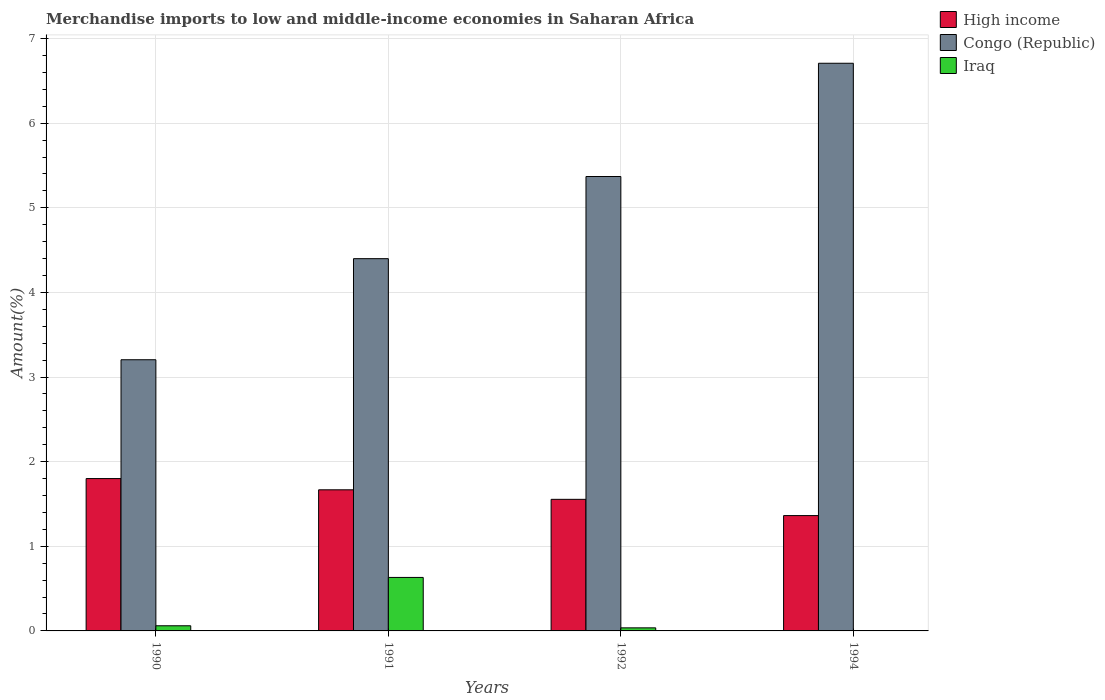How many different coloured bars are there?
Keep it short and to the point. 3. Are the number of bars per tick equal to the number of legend labels?
Offer a terse response. Yes. Are the number of bars on each tick of the X-axis equal?
Your answer should be very brief. Yes. How many bars are there on the 4th tick from the right?
Offer a very short reply. 3. In how many cases, is the number of bars for a given year not equal to the number of legend labels?
Provide a succinct answer. 0. What is the percentage of amount earned from merchandise imports in Iraq in 1990?
Give a very brief answer. 0.06. Across all years, what is the maximum percentage of amount earned from merchandise imports in High income?
Offer a very short reply. 1.8. Across all years, what is the minimum percentage of amount earned from merchandise imports in High income?
Your answer should be very brief. 1.36. In which year was the percentage of amount earned from merchandise imports in High income minimum?
Ensure brevity in your answer.  1994. What is the total percentage of amount earned from merchandise imports in High income in the graph?
Keep it short and to the point. 6.39. What is the difference between the percentage of amount earned from merchandise imports in Iraq in 1990 and that in 1994?
Make the answer very short. 0.06. What is the difference between the percentage of amount earned from merchandise imports in Congo (Republic) in 1994 and the percentage of amount earned from merchandise imports in Iraq in 1990?
Provide a succinct answer. 6.65. What is the average percentage of amount earned from merchandise imports in Congo (Republic) per year?
Give a very brief answer. 4.92. In the year 1992, what is the difference between the percentage of amount earned from merchandise imports in Congo (Republic) and percentage of amount earned from merchandise imports in Iraq?
Ensure brevity in your answer.  5.33. What is the ratio of the percentage of amount earned from merchandise imports in Iraq in 1991 to that in 1994?
Ensure brevity in your answer.  8368.13. What is the difference between the highest and the second highest percentage of amount earned from merchandise imports in Iraq?
Give a very brief answer. 0.57. What is the difference between the highest and the lowest percentage of amount earned from merchandise imports in High income?
Your answer should be compact. 0.44. Is the sum of the percentage of amount earned from merchandise imports in Congo (Republic) in 1991 and 1994 greater than the maximum percentage of amount earned from merchandise imports in High income across all years?
Your answer should be compact. Yes. What does the 3rd bar from the left in 1990 represents?
Provide a short and direct response. Iraq. What does the 1st bar from the right in 1990 represents?
Keep it short and to the point. Iraq. Is it the case that in every year, the sum of the percentage of amount earned from merchandise imports in Congo (Republic) and percentage of amount earned from merchandise imports in Iraq is greater than the percentage of amount earned from merchandise imports in High income?
Give a very brief answer. Yes. How are the legend labels stacked?
Provide a succinct answer. Vertical. What is the title of the graph?
Your answer should be compact. Merchandise imports to low and middle-income economies in Saharan Africa. What is the label or title of the X-axis?
Make the answer very short. Years. What is the label or title of the Y-axis?
Provide a short and direct response. Amount(%). What is the Amount(%) in High income in 1990?
Offer a very short reply. 1.8. What is the Amount(%) in Congo (Republic) in 1990?
Your answer should be very brief. 3.2. What is the Amount(%) in Iraq in 1990?
Keep it short and to the point. 0.06. What is the Amount(%) of High income in 1991?
Make the answer very short. 1.67. What is the Amount(%) in Congo (Republic) in 1991?
Your answer should be compact. 4.4. What is the Amount(%) of Iraq in 1991?
Ensure brevity in your answer.  0.63. What is the Amount(%) of High income in 1992?
Ensure brevity in your answer.  1.56. What is the Amount(%) of Congo (Republic) in 1992?
Ensure brevity in your answer.  5.37. What is the Amount(%) of Iraq in 1992?
Your answer should be very brief. 0.04. What is the Amount(%) of High income in 1994?
Ensure brevity in your answer.  1.36. What is the Amount(%) of Congo (Republic) in 1994?
Offer a very short reply. 6.71. What is the Amount(%) of Iraq in 1994?
Provide a short and direct response. 7.554784853766509e-5. Across all years, what is the maximum Amount(%) in High income?
Provide a short and direct response. 1.8. Across all years, what is the maximum Amount(%) in Congo (Republic)?
Offer a very short reply. 6.71. Across all years, what is the maximum Amount(%) in Iraq?
Make the answer very short. 0.63. Across all years, what is the minimum Amount(%) of High income?
Your answer should be compact. 1.36. Across all years, what is the minimum Amount(%) in Congo (Republic)?
Provide a short and direct response. 3.2. Across all years, what is the minimum Amount(%) of Iraq?
Make the answer very short. 7.554784853766509e-5. What is the total Amount(%) in High income in the graph?
Provide a short and direct response. 6.39. What is the total Amount(%) in Congo (Republic) in the graph?
Your answer should be compact. 19.68. What is the total Amount(%) of Iraq in the graph?
Your answer should be very brief. 0.73. What is the difference between the Amount(%) in High income in 1990 and that in 1991?
Provide a succinct answer. 0.13. What is the difference between the Amount(%) in Congo (Republic) in 1990 and that in 1991?
Your answer should be compact. -1.19. What is the difference between the Amount(%) in Iraq in 1990 and that in 1991?
Ensure brevity in your answer.  -0.57. What is the difference between the Amount(%) of High income in 1990 and that in 1992?
Give a very brief answer. 0.25. What is the difference between the Amount(%) of Congo (Republic) in 1990 and that in 1992?
Offer a very short reply. -2.17. What is the difference between the Amount(%) of Iraq in 1990 and that in 1992?
Offer a very short reply. 0.02. What is the difference between the Amount(%) of High income in 1990 and that in 1994?
Make the answer very short. 0.44. What is the difference between the Amount(%) of Congo (Republic) in 1990 and that in 1994?
Give a very brief answer. -3.5. What is the difference between the Amount(%) of Iraq in 1990 and that in 1994?
Your answer should be compact. 0.06. What is the difference between the Amount(%) of High income in 1991 and that in 1992?
Provide a succinct answer. 0.11. What is the difference between the Amount(%) in Congo (Republic) in 1991 and that in 1992?
Your response must be concise. -0.97. What is the difference between the Amount(%) in Iraq in 1991 and that in 1992?
Your response must be concise. 0.6. What is the difference between the Amount(%) of High income in 1991 and that in 1994?
Make the answer very short. 0.3. What is the difference between the Amount(%) in Congo (Republic) in 1991 and that in 1994?
Make the answer very short. -2.31. What is the difference between the Amount(%) in Iraq in 1991 and that in 1994?
Provide a short and direct response. 0.63. What is the difference between the Amount(%) in High income in 1992 and that in 1994?
Your answer should be very brief. 0.19. What is the difference between the Amount(%) in Congo (Republic) in 1992 and that in 1994?
Ensure brevity in your answer.  -1.34. What is the difference between the Amount(%) in Iraq in 1992 and that in 1994?
Provide a short and direct response. 0.04. What is the difference between the Amount(%) of High income in 1990 and the Amount(%) of Congo (Republic) in 1991?
Ensure brevity in your answer.  -2.6. What is the difference between the Amount(%) of High income in 1990 and the Amount(%) of Iraq in 1991?
Provide a succinct answer. 1.17. What is the difference between the Amount(%) in Congo (Republic) in 1990 and the Amount(%) in Iraq in 1991?
Provide a short and direct response. 2.57. What is the difference between the Amount(%) of High income in 1990 and the Amount(%) of Congo (Republic) in 1992?
Make the answer very short. -3.57. What is the difference between the Amount(%) in High income in 1990 and the Amount(%) in Iraq in 1992?
Your answer should be compact. 1.76. What is the difference between the Amount(%) in Congo (Republic) in 1990 and the Amount(%) in Iraq in 1992?
Make the answer very short. 3.17. What is the difference between the Amount(%) of High income in 1990 and the Amount(%) of Congo (Republic) in 1994?
Offer a very short reply. -4.91. What is the difference between the Amount(%) of High income in 1990 and the Amount(%) of Iraq in 1994?
Your answer should be compact. 1.8. What is the difference between the Amount(%) in Congo (Republic) in 1990 and the Amount(%) in Iraq in 1994?
Ensure brevity in your answer.  3.2. What is the difference between the Amount(%) of High income in 1991 and the Amount(%) of Congo (Republic) in 1992?
Your answer should be compact. -3.7. What is the difference between the Amount(%) of High income in 1991 and the Amount(%) of Iraq in 1992?
Your response must be concise. 1.63. What is the difference between the Amount(%) of Congo (Republic) in 1991 and the Amount(%) of Iraq in 1992?
Offer a very short reply. 4.36. What is the difference between the Amount(%) of High income in 1991 and the Amount(%) of Congo (Republic) in 1994?
Your answer should be very brief. -5.04. What is the difference between the Amount(%) of High income in 1991 and the Amount(%) of Iraq in 1994?
Your response must be concise. 1.67. What is the difference between the Amount(%) in Congo (Republic) in 1991 and the Amount(%) in Iraq in 1994?
Give a very brief answer. 4.4. What is the difference between the Amount(%) in High income in 1992 and the Amount(%) in Congo (Republic) in 1994?
Keep it short and to the point. -5.15. What is the difference between the Amount(%) of High income in 1992 and the Amount(%) of Iraq in 1994?
Offer a very short reply. 1.55. What is the difference between the Amount(%) of Congo (Republic) in 1992 and the Amount(%) of Iraq in 1994?
Give a very brief answer. 5.37. What is the average Amount(%) in High income per year?
Ensure brevity in your answer.  1.6. What is the average Amount(%) in Congo (Republic) per year?
Ensure brevity in your answer.  4.92. What is the average Amount(%) of Iraq per year?
Your response must be concise. 0.18. In the year 1990, what is the difference between the Amount(%) in High income and Amount(%) in Congo (Republic)?
Your answer should be compact. -1.4. In the year 1990, what is the difference between the Amount(%) of High income and Amount(%) of Iraq?
Keep it short and to the point. 1.74. In the year 1990, what is the difference between the Amount(%) in Congo (Republic) and Amount(%) in Iraq?
Ensure brevity in your answer.  3.14. In the year 1991, what is the difference between the Amount(%) of High income and Amount(%) of Congo (Republic)?
Your response must be concise. -2.73. In the year 1991, what is the difference between the Amount(%) in High income and Amount(%) in Iraq?
Your answer should be compact. 1.04. In the year 1991, what is the difference between the Amount(%) in Congo (Republic) and Amount(%) in Iraq?
Your response must be concise. 3.77. In the year 1992, what is the difference between the Amount(%) in High income and Amount(%) in Congo (Republic)?
Your response must be concise. -3.82. In the year 1992, what is the difference between the Amount(%) of High income and Amount(%) of Iraq?
Make the answer very short. 1.52. In the year 1992, what is the difference between the Amount(%) of Congo (Republic) and Amount(%) of Iraq?
Offer a very short reply. 5.33. In the year 1994, what is the difference between the Amount(%) of High income and Amount(%) of Congo (Republic)?
Keep it short and to the point. -5.35. In the year 1994, what is the difference between the Amount(%) in High income and Amount(%) in Iraq?
Give a very brief answer. 1.36. In the year 1994, what is the difference between the Amount(%) in Congo (Republic) and Amount(%) in Iraq?
Offer a terse response. 6.71. What is the ratio of the Amount(%) of High income in 1990 to that in 1991?
Make the answer very short. 1.08. What is the ratio of the Amount(%) of Congo (Republic) in 1990 to that in 1991?
Make the answer very short. 0.73. What is the ratio of the Amount(%) of Iraq in 1990 to that in 1991?
Your response must be concise. 0.1. What is the ratio of the Amount(%) of High income in 1990 to that in 1992?
Your answer should be compact. 1.16. What is the ratio of the Amount(%) in Congo (Republic) in 1990 to that in 1992?
Ensure brevity in your answer.  0.6. What is the ratio of the Amount(%) of Iraq in 1990 to that in 1992?
Offer a terse response. 1.68. What is the ratio of the Amount(%) of High income in 1990 to that in 1994?
Your response must be concise. 1.32. What is the ratio of the Amount(%) of Congo (Republic) in 1990 to that in 1994?
Offer a terse response. 0.48. What is the ratio of the Amount(%) in Iraq in 1990 to that in 1994?
Give a very brief answer. 804.57. What is the ratio of the Amount(%) of High income in 1991 to that in 1992?
Make the answer very short. 1.07. What is the ratio of the Amount(%) of Congo (Republic) in 1991 to that in 1992?
Offer a very short reply. 0.82. What is the ratio of the Amount(%) of Iraq in 1991 to that in 1992?
Keep it short and to the point. 17.47. What is the ratio of the Amount(%) in High income in 1991 to that in 1994?
Provide a succinct answer. 1.22. What is the ratio of the Amount(%) of Congo (Republic) in 1991 to that in 1994?
Your answer should be very brief. 0.66. What is the ratio of the Amount(%) in Iraq in 1991 to that in 1994?
Provide a short and direct response. 8368.13. What is the ratio of the Amount(%) of High income in 1992 to that in 1994?
Keep it short and to the point. 1.14. What is the ratio of the Amount(%) in Congo (Republic) in 1992 to that in 1994?
Your answer should be compact. 0.8. What is the ratio of the Amount(%) of Iraq in 1992 to that in 1994?
Provide a short and direct response. 479.08. What is the difference between the highest and the second highest Amount(%) of High income?
Provide a short and direct response. 0.13. What is the difference between the highest and the second highest Amount(%) of Congo (Republic)?
Make the answer very short. 1.34. What is the difference between the highest and the lowest Amount(%) of High income?
Offer a very short reply. 0.44. What is the difference between the highest and the lowest Amount(%) of Congo (Republic)?
Ensure brevity in your answer.  3.5. What is the difference between the highest and the lowest Amount(%) of Iraq?
Your answer should be very brief. 0.63. 